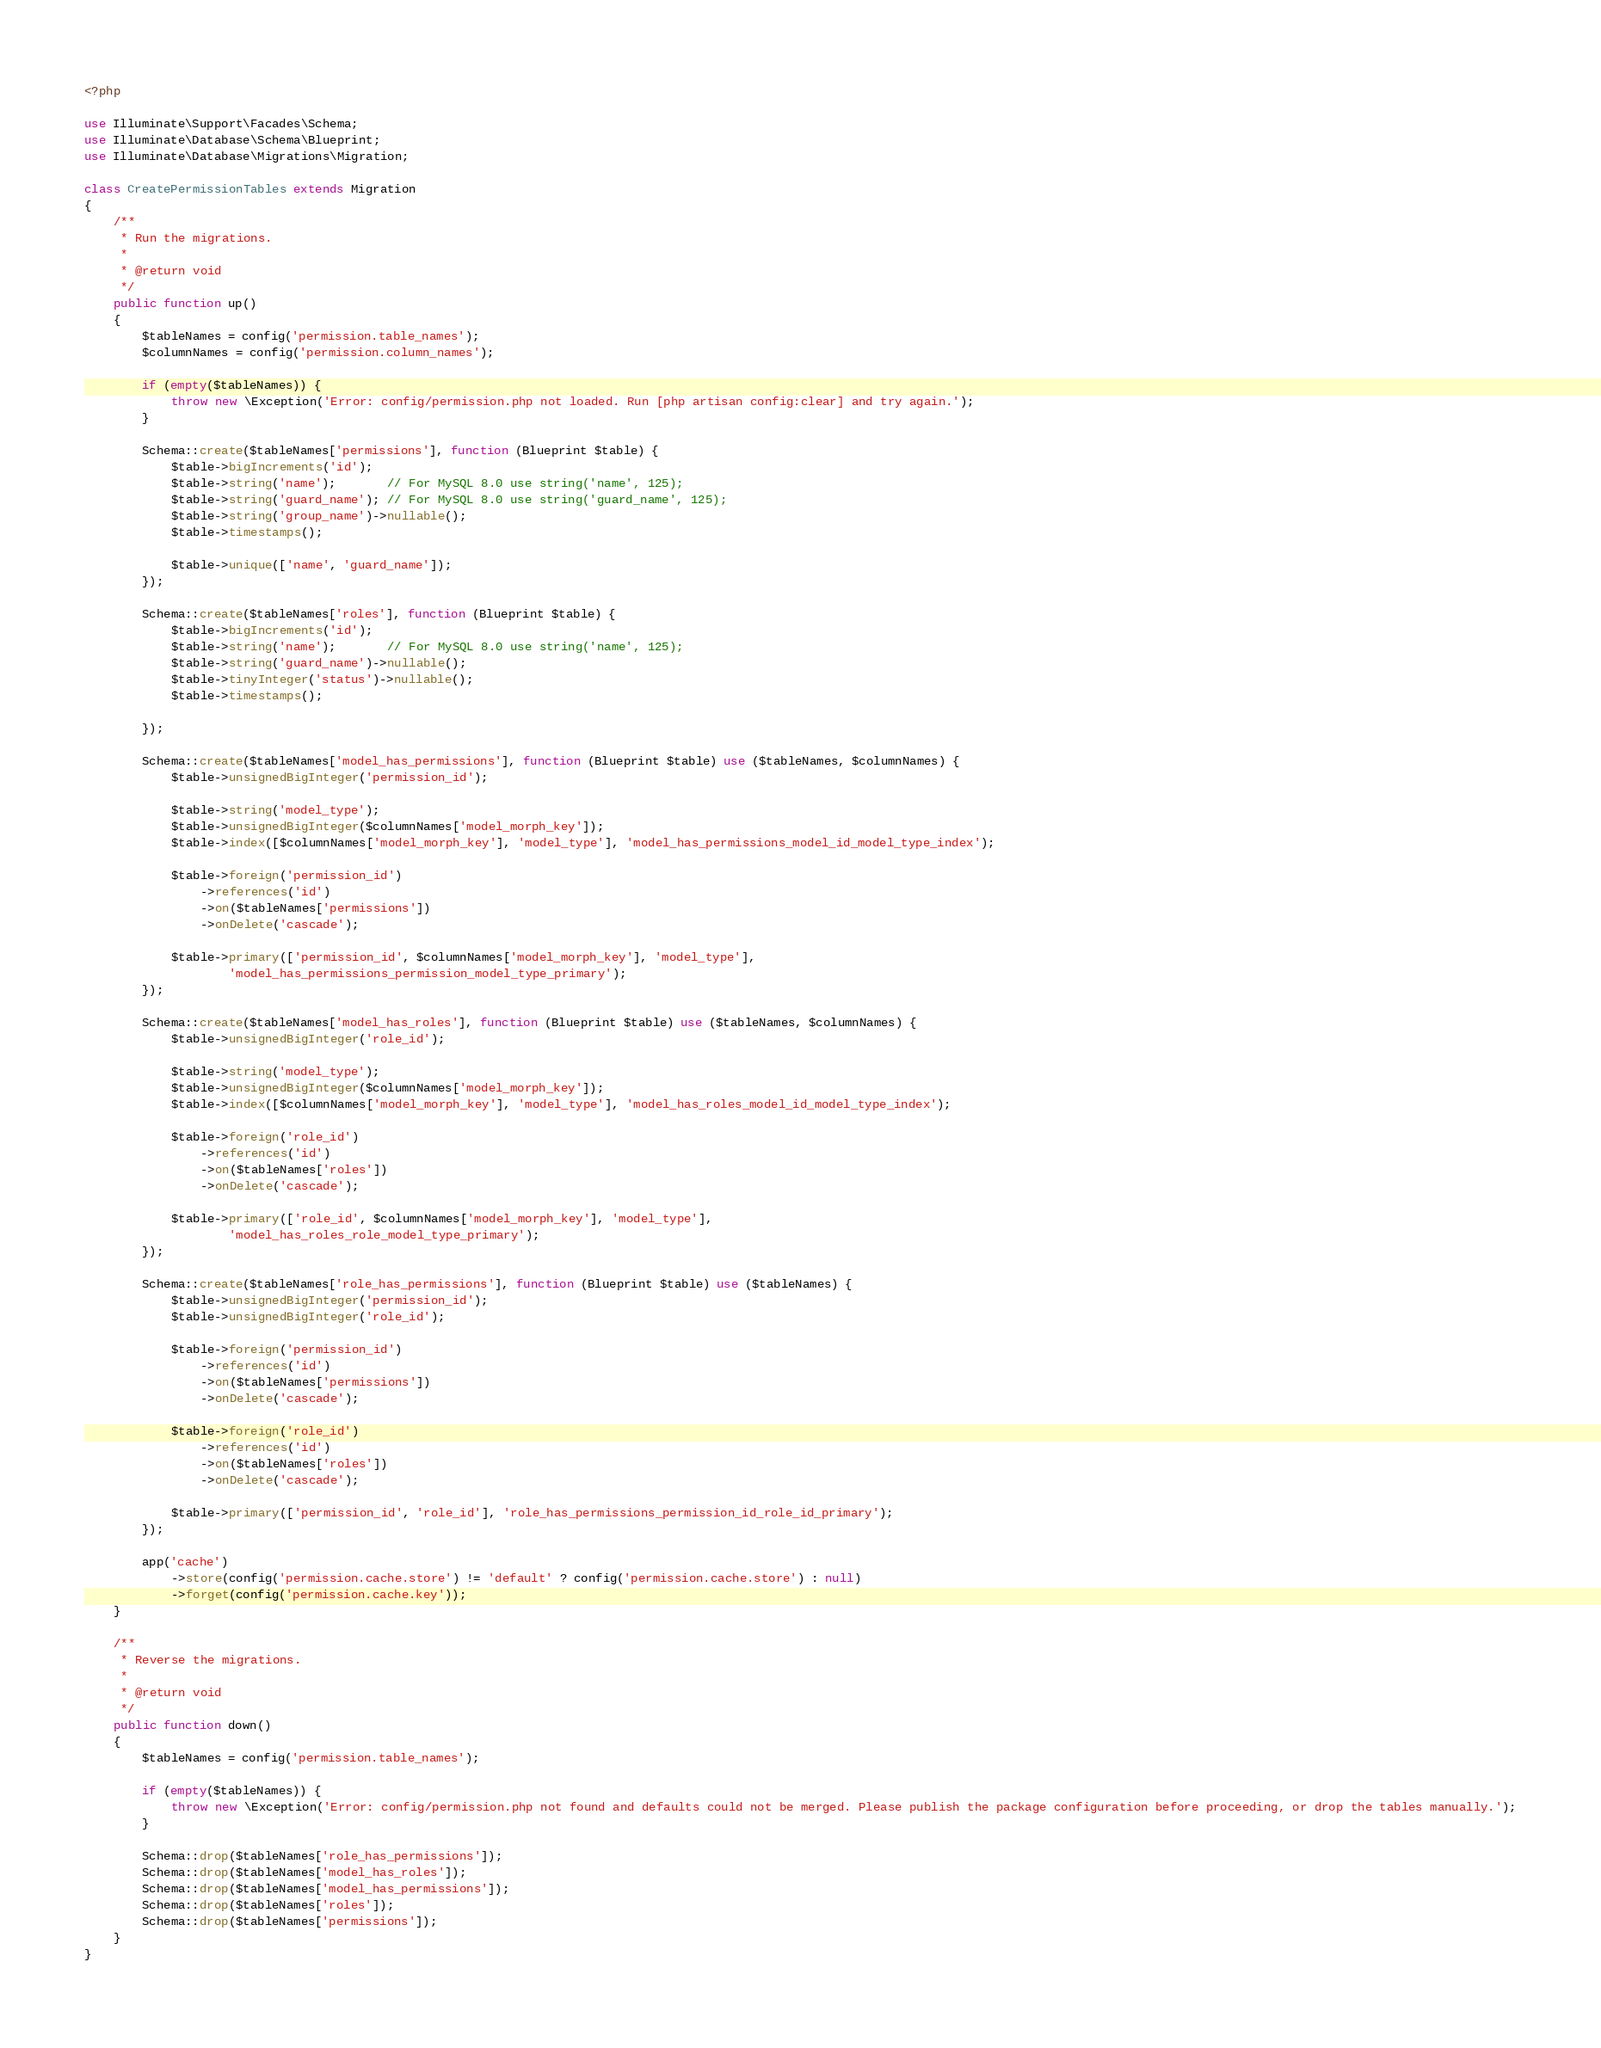Convert code to text. <code><loc_0><loc_0><loc_500><loc_500><_PHP_><?php

use Illuminate\Support\Facades\Schema;
use Illuminate\Database\Schema\Blueprint;
use Illuminate\Database\Migrations\Migration;

class CreatePermissionTables extends Migration
{
    /**
     * Run the migrations.
     *
     * @return void
     */
    public function up()
    {
        $tableNames = config('permission.table_names');
        $columnNames = config('permission.column_names');

        if (empty($tableNames)) {
            throw new \Exception('Error: config/permission.php not loaded. Run [php artisan config:clear] and try again.');
        }

        Schema::create($tableNames['permissions'], function (Blueprint $table) {
            $table->bigIncrements('id');
            $table->string('name');       // For MySQL 8.0 use string('name', 125);
            $table->string('guard_name'); // For MySQL 8.0 use string('guard_name', 125);
            $table->string('group_name')->nullable();
            $table->timestamps();

            $table->unique(['name', 'guard_name']);
        });

        Schema::create($tableNames['roles'], function (Blueprint $table) {
            $table->bigIncrements('id');
            $table->string('name');       // For MySQL 8.0 use string('name', 125);
            $table->string('guard_name')->nullable();
            $table->tinyInteger('status')->nullable();
            $table->timestamps();

        });

        Schema::create($tableNames['model_has_permissions'], function (Blueprint $table) use ($tableNames, $columnNames) {
            $table->unsignedBigInteger('permission_id');

            $table->string('model_type');
            $table->unsignedBigInteger($columnNames['model_morph_key']);
            $table->index([$columnNames['model_morph_key'], 'model_type'], 'model_has_permissions_model_id_model_type_index');

            $table->foreign('permission_id')
                ->references('id')
                ->on($tableNames['permissions'])
                ->onDelete('cascade');

            $table->primary(['permission_id', $columnNames['model_morph_key'], 'model_type'],
                    'model_has_permissions_permission_model_type_primary');
        });

        Schema::create($tableNames['model_has_roles'], function (Blueprint $table) use ($tableNames, $columnNames) {
            $table->unsignedBigInteger('role_id');

            $table->string('model_type');
            $table->unsignedBigInteger($columnNames['model_morph_key']);
            $table->index([$columnNames['model_morph_key'], 'model_type'], 'model_has_roles_model_id_model_type_index');

            $table->foreign('role_id')
                ->references('id')
                ->on($tableNames['roles'])
                ->onDelete('cascade');

            $table->primary(['role_id', $columnNames['model_morph_key'], 'model_type'],
                    'model_has_roles_role_model_type_primary');
        });

        Schema::create($tableNames['role_has_permissions'], function (Blueprint $table) use ($tableNames) {
            $table->unsignedBigInteger('permission_id');
            $table->unsignedBigInteger('role_id');

            $table->foreign('permission_id')
                ->references('id')
                ->on($tableNames['permissions'])
                ->onDelete('cascade');

            $table->foreign('role_id')
                ->references('id')
                ->on($tableNames['roles'])
                ->onDelete('cascade');

            $table->primary(['permission_id', 'role_id'], 'role_has_permissions_permission_id_role_id_primary');
        });

        app('cache')
            ->store(config('permission.cache.store') != 'default' ? config('permission.cache.store') : null)
            ->forget(config('permission.cache.key'));
    }

    /**
     * Reverse the migrations.
     *
     * @return void
     */
    public function down()
    {
        $tableNames = config('permission.table_names');

        if (empty($tableNames)) {
            throw new \Exception('Error: config/permission.php not found and defaults could not be merged. Please publish the package configuration before proceeding, or drop the tables manually.');
        }

        Schema::drop($tableNames['role_has_permissions']);
        Schema::drop($tableNames['model_has_roles']);
        Schema::drop($tableNames['model_has_permissions']);
        Schema::drop($tableNames['roles']);
        Schema::drop($tableNames['permissions']);
    }
}
</code> 